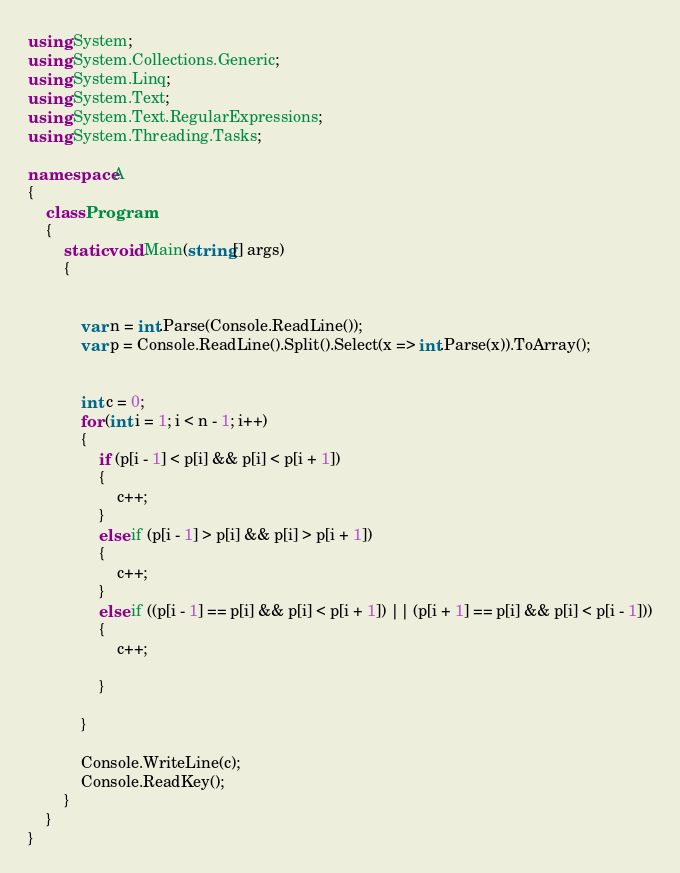Convert code to text. <code><loc_0><loc_0><loc_500><loc_500><_C#_>using System;
using System.Collections.Generic;
using System.Linq;
using System.Text;
using System.Text.RegularExpressions;
using System.Threading.Tasks;

namespace A
{
    class Program
    {
        static void Main(string[] args)
        {


            var n = int.Parse(Console.ReadLine());
            var p = Console.ReadLine().Split().Select(x => int.Parse(x)).ToArray();


            int c = 0;
            for (int i = 1; i < n - 1; i++)
            {
                if (p[i - 1] < p[i] && p[i] < p[i + 1])
                {
                    c++;
                }
                else if (p[i - 1] > p[i] && p[i] > p[i + 1])
                {
                    c++;
                }
                else if ((p[i - 1] == p[i] && p[i] < p[i + 1]) || (p[i + 1] == p[i] && p[i] < p[i - 1]))
                {
                    c++;

                }

            }

            Console.WriteLine(c);
            Console.ReadKey();
        }
    }
}</code> 